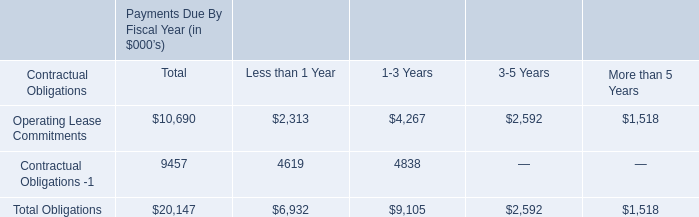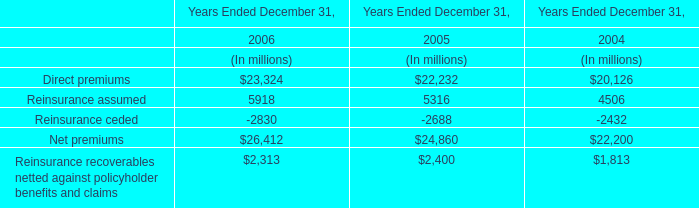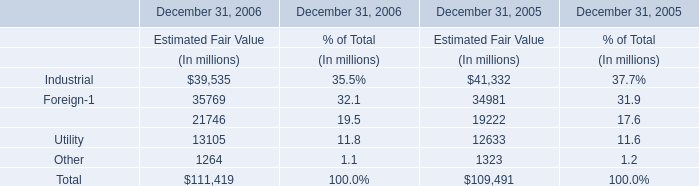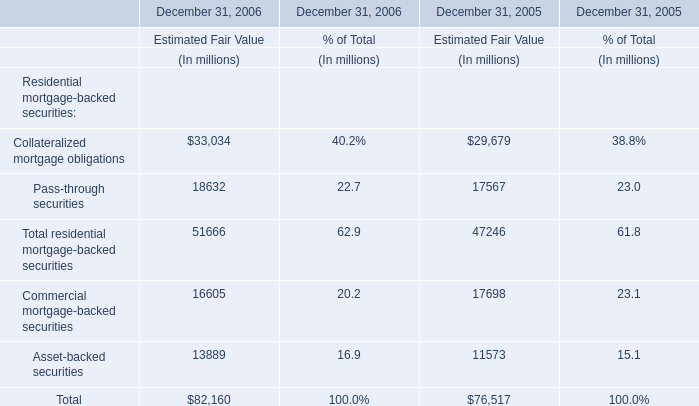What is the sum of elements in the range of 30000 and 40000 in 2006? (in million) 
Computations: (39535 + 35769)
Answer: 75304.0. 